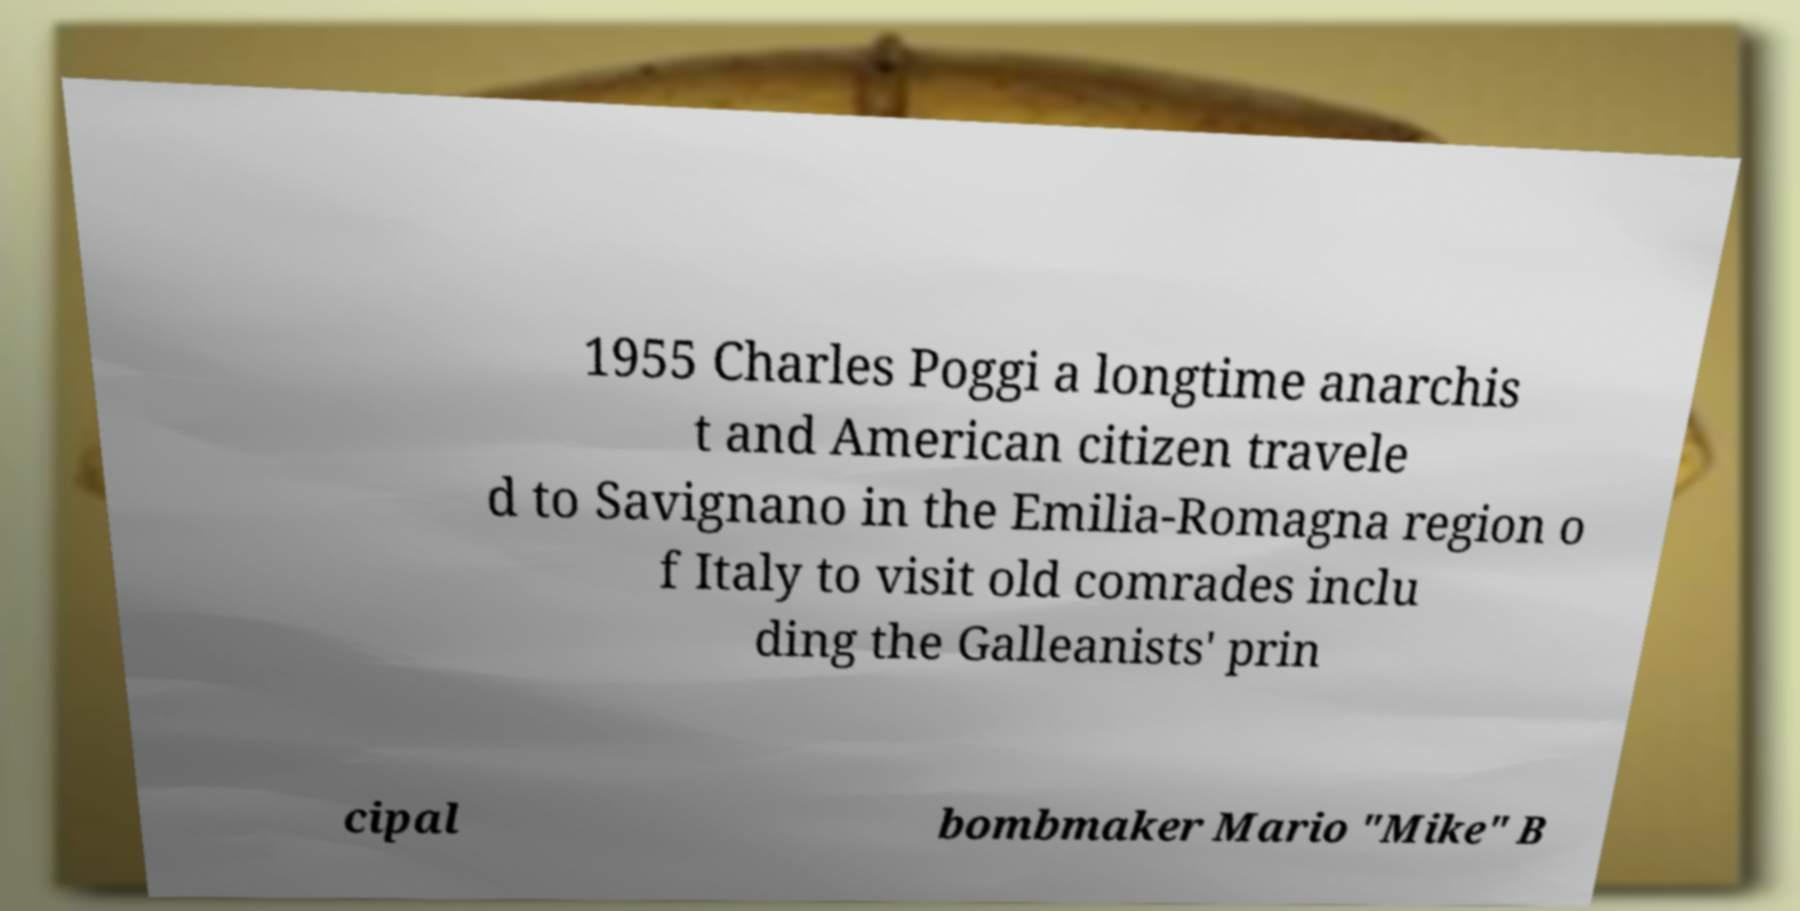Please identify and transcribe the text found in this image. 1955 Charles Poggi a longtime anarchis t and American citizen travele d to Savignano in the Emilia-Romagna region o f Italy to visit old comrades inclu ding the Galleanists' prin cipal bombmaker Mario "Mike" B 